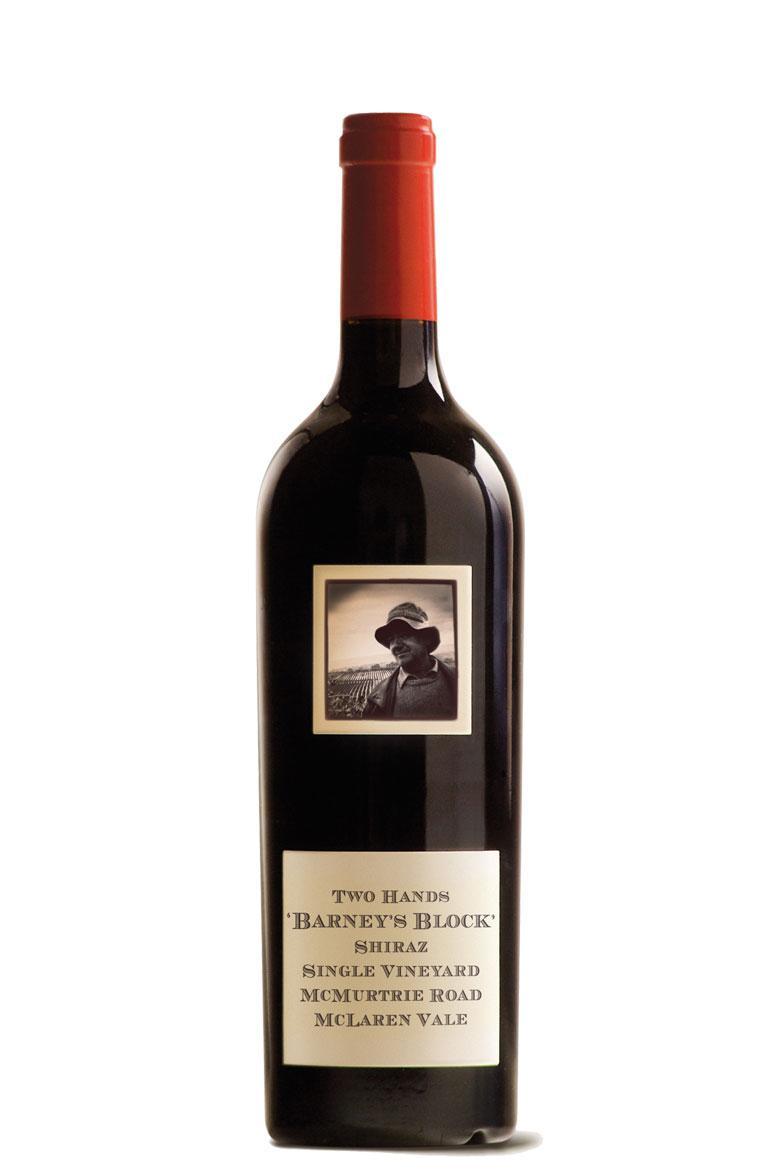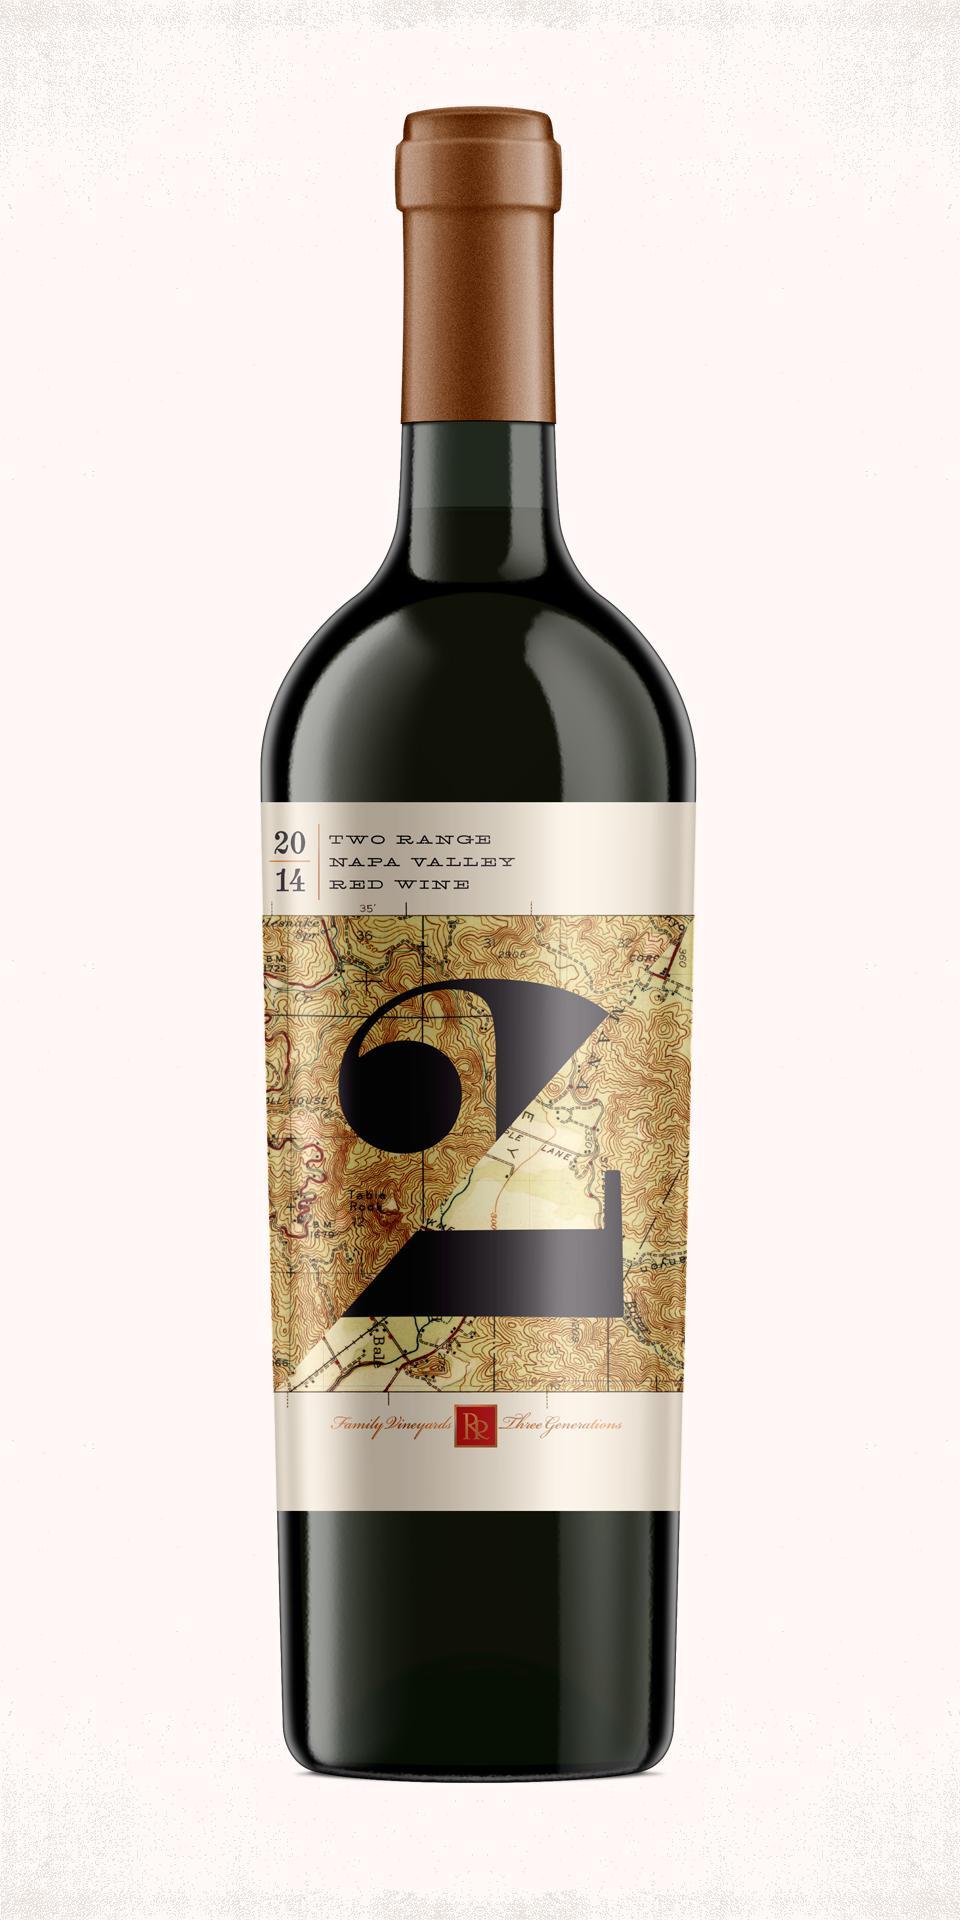The first image is the image on the left, the second image is the image on the right. Evaluate the accuracy of this statement regarding the images: "There is at least 1 wine bottle with a red cap.". Is it true? Answer yes or no. Yes. 